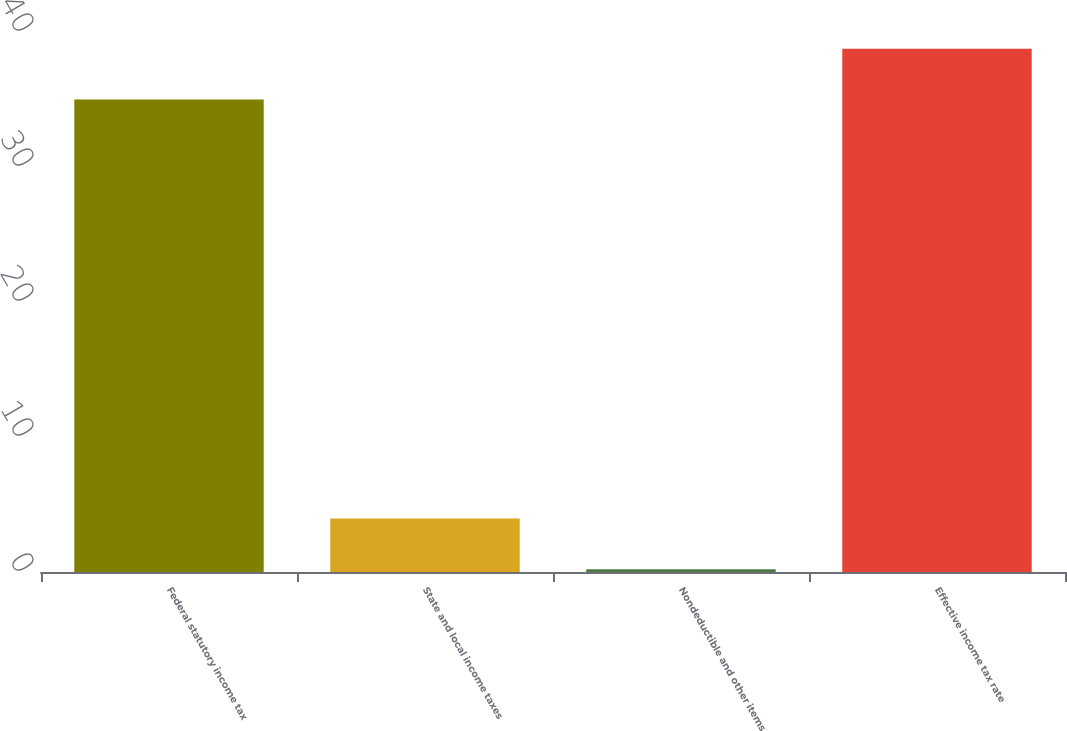Convert chart to OTSL. <chart><loc_0><loc_0><loc_500><loc_500><bar_chart><fcel>Federal statutory income tax<fcel>State and local income taxes<fcel>Nondeductible and other items<fcel>Effective income tax rate<nl><fcel>35<fcel>3.96<fcel>0.2<fcel>38.76<nl></chart> 